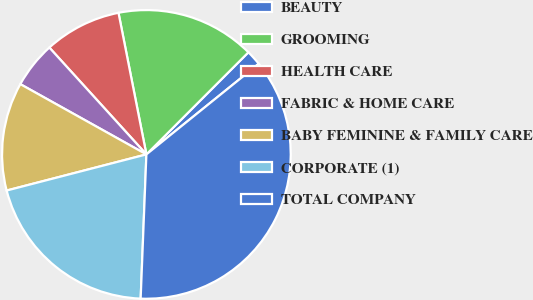Convert chart to OTSL. <chart><loc_0><loc_0><loc_500><loc_500><pie_chart><fcel>BEAUTY<fcel>GROOMING<fcel>HEALTH CARE<fcel>FABRIC & HOME CARE<fcel>BABY FEMININE & FAMILY CARE<fcel>CORPORATE (1)<fcel>TOTAL COMPANY<nl><fcel>1.7%<fcel>15.59%<fcel>8.64%<fcel>5.17%<fcel>12.12%<fcel>20.34%<fcel>36.44%<nl></chart> 